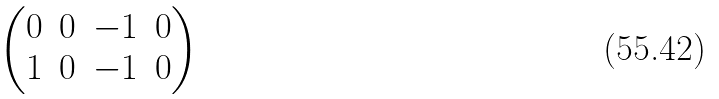<formula> <loc_0><loc_0><loc_500><loc_500>\begin{pmatrix} 0 & 0 & - 1 & 0 \\ 1 & 0 & - 1 & 0 \end{pmatrix}</formula> 